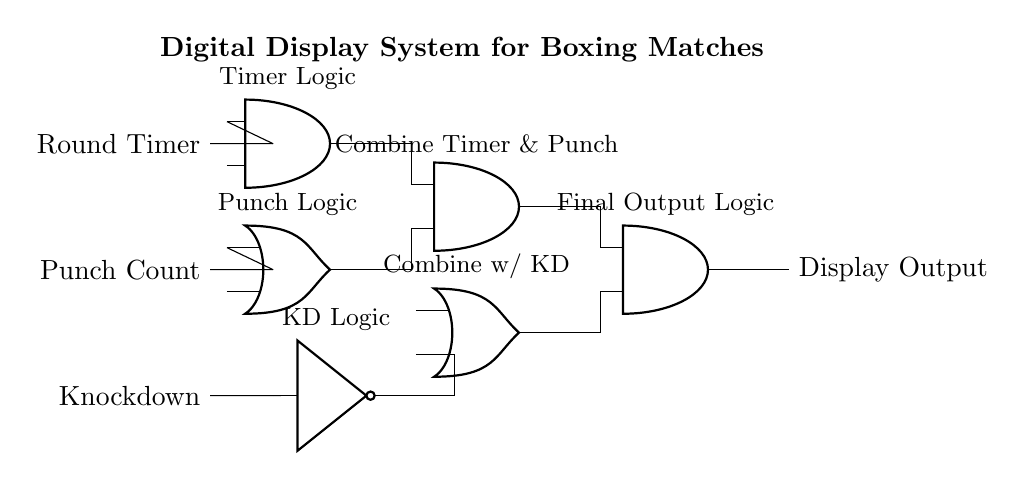What is the display output of this circuit? The output of the circuit is derived from the AND3 gate, which processes the results of the previous logic gates. The display output will show the final combined logic based on the Round Timer, Punch Count, and Knockdown signals.
Answer: Display Output How many logic gates are in this circuit? Upon inspection of the circuit diagram, there are five logic gates: three AND gates, one OR gate, and one NOT gate.
Answer: Five Which logic gate processes the Punch Count? The OR gate (OR1) processes the Punch Count alongside the Round Timer input. It takes the Punch Count signal and combines it with the Round Timer for further logic.
Answer: OR1 What does the NOT gate represent in this circuit? The NOT gate (NOT1) in this circuit represents the Knockdown signal logic, which inverts the input Knockdown signal to inform subsequent gate operations.
Answer: Knockdown signal logic What is the function of AND2 in the circuit? AND2 combines the outputs of AND1 (from the timer logic) and OR1 (from the punch logic) to create a result that includes both round timing and punch counting information.
Answer: Combine Timer & Punch What are the input signals to this display system? The circuit has three main input signals: Round Timer, Punch Count, and Knockdown. Each of these inputs plays a crucial role in determining the logic of the display output.
Answer: Round Timer, Punch Count, Knockdown What logic type does this system primarily employ? The primary logic type used in this digital display system is combinational logic, as it utilizes various logic gates to yield a final output based on multiple inputs without feedback loops.
Answer: Combinational logic 